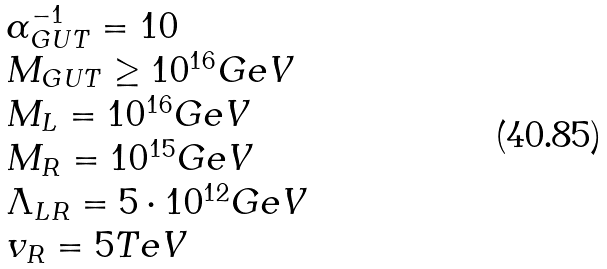<formula> <loc_0><loc_0><loc_500><loc_500>\begin{array} { l } \alpha _ { G U T } ^ { - 1 } = 1 0 \\ M _ { G U T } \geq 1 0 ^ { 1 6 } G e V \\ M _ { L } = 1 0 ^ { 1 6 } G e V \\ M _ { R } = 1 0 ^ { 1 5 } G e V \\ \Lambda _ { L R } = 5 \cdot 1 0 ^ { 1 2 } G e V \\ v _ { R } = 5 T e V \\ \end{array}</formula> 